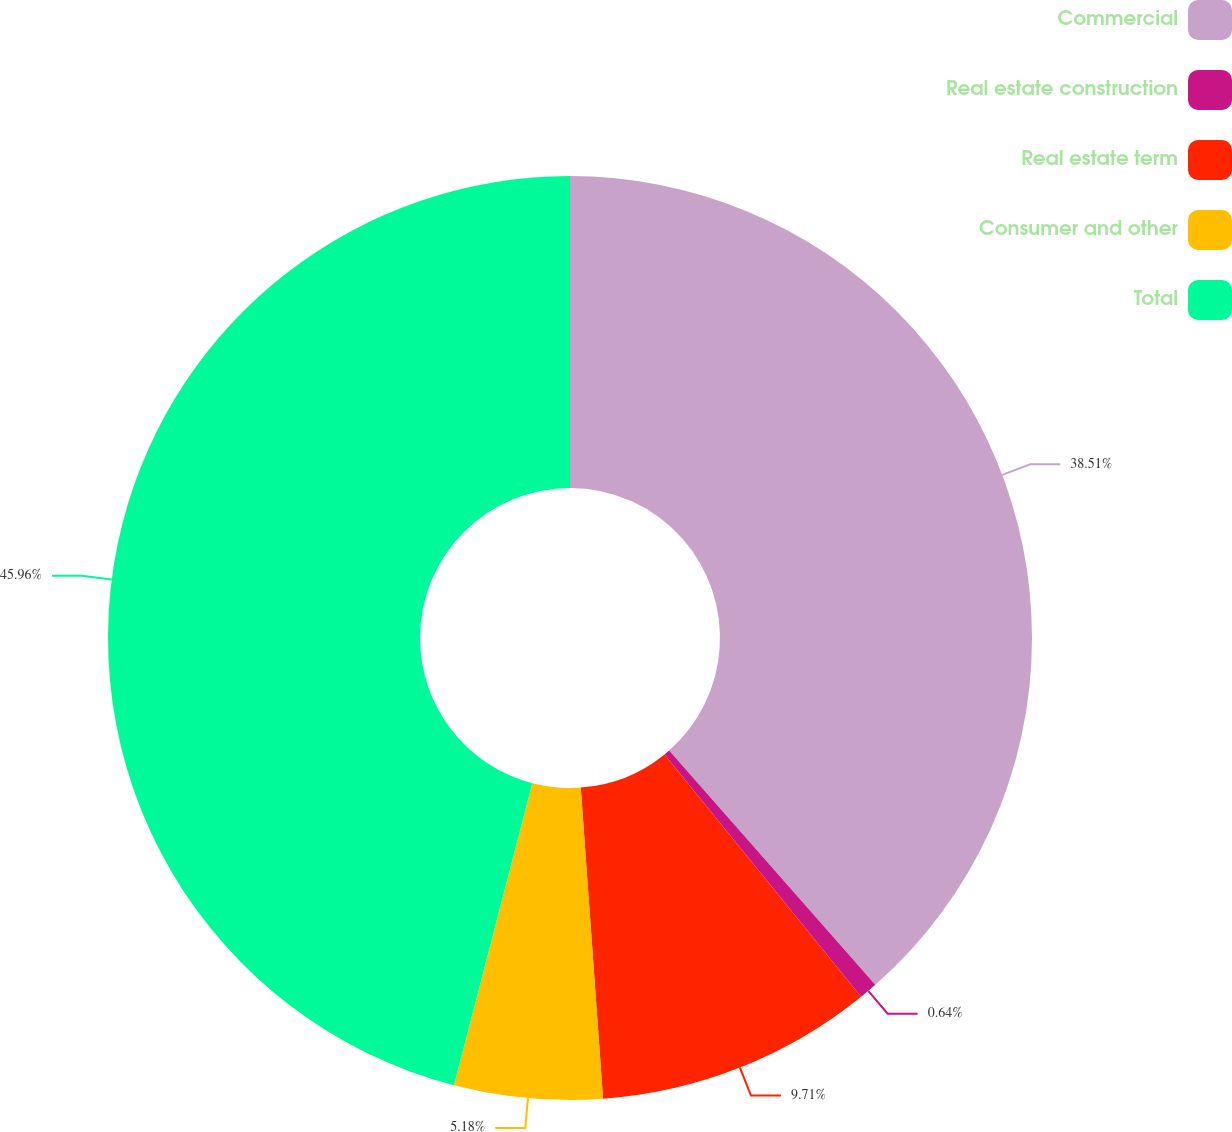<chart> <loc_0><loc_0><loc_500><loc_500><pie_chart><fcel>Commercial<fcel>Real estate construction<fcel>Real estate term<fcel>Consumer and other<fcel>Total<nl><fcel>38.51%<fcel>0.64%<fcel>9.71%<fcel>5.18%<fcel>45.96%<nl></chart> 